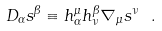<formula> <loc_0><loc_0><loc_500><loc_500>D _ { \alpha } s ^ { \beta } \equiv h ^ { \mu } _ { \alpha } h ^ { \beta } _ { \nu } \nabla _ { \mu } s ^ { \nu } \ .</formula> 